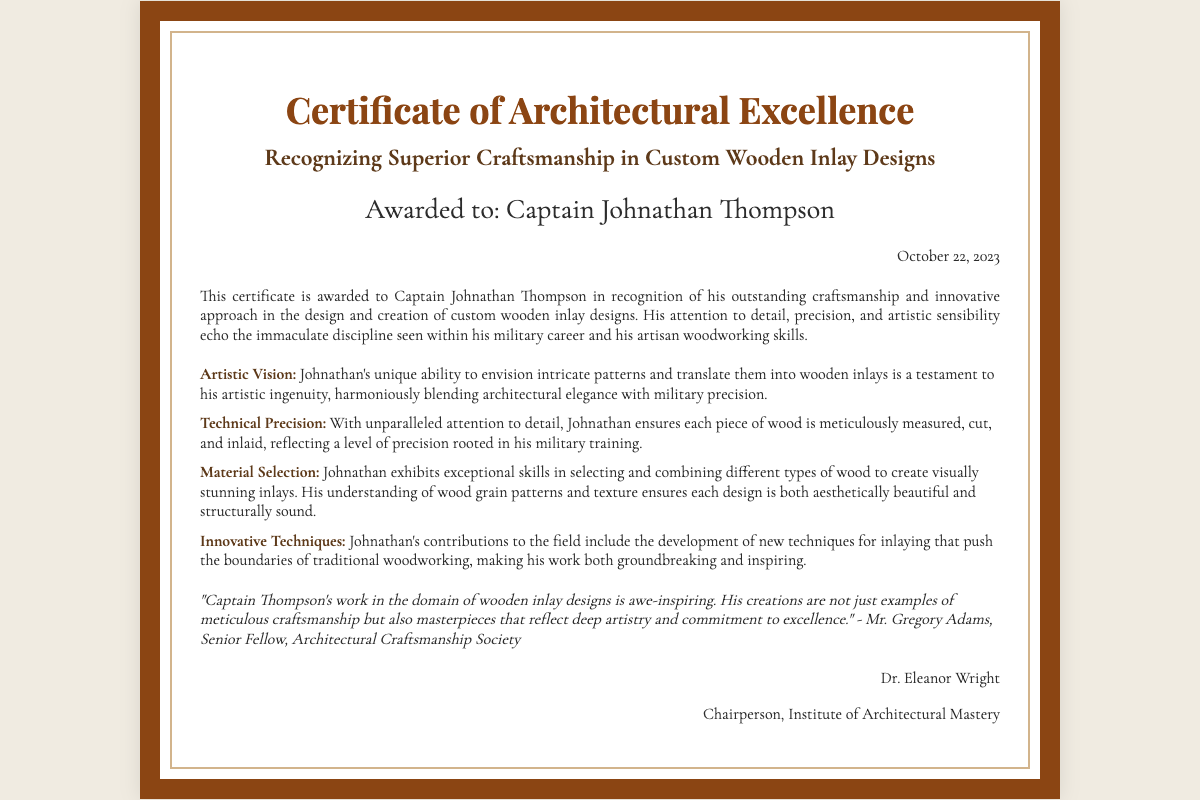What is the title of the certificate? The title can be found prominently at the top of the document and is crucial for identifying its purpose.
Answer: Certificate of Architectural Excellence Who is the recipient of the certificate? The recipient's name is stated clearly below the title of the certificate.
Answer: Captain Johnathan Thompson What date was the certificate awarded? The date is mentioned in a specific section of the document, indicating when the award was given.
Answer: October 22, 2023 What quality does Johnathan demonstrate through his artistic vision? This aspect is detailed in the achievements section, highlighting Johnathan's creative ability.
Answer: Artistic ingenuity What type of design is recognized in this certificate? The design type is described in the title and main heading of the document.
Answer: Custom wooden inlay designs Who provided a testimonial about Captain Thompson's work? The testimonial section of the document includes the name of the person providing the recognition.
Answer: Mr. Gregory Adams What organization is Dr. Eleanor Wright associated with? The signature section of the document reveals the organization the chairperson represents.
Answer: Institute of Architectural Mastery What aspect of craftsmanship is highlighted by Johnathan's technical precision? The achievements section discusses the skill involved in creating his designs.
Answer: Attention to detail How does Johnathan's material selection contribute to his designs? The achievement related to material selection outlines the significance of this skill in his work.
Answer: Visually stunning and structurally sound 